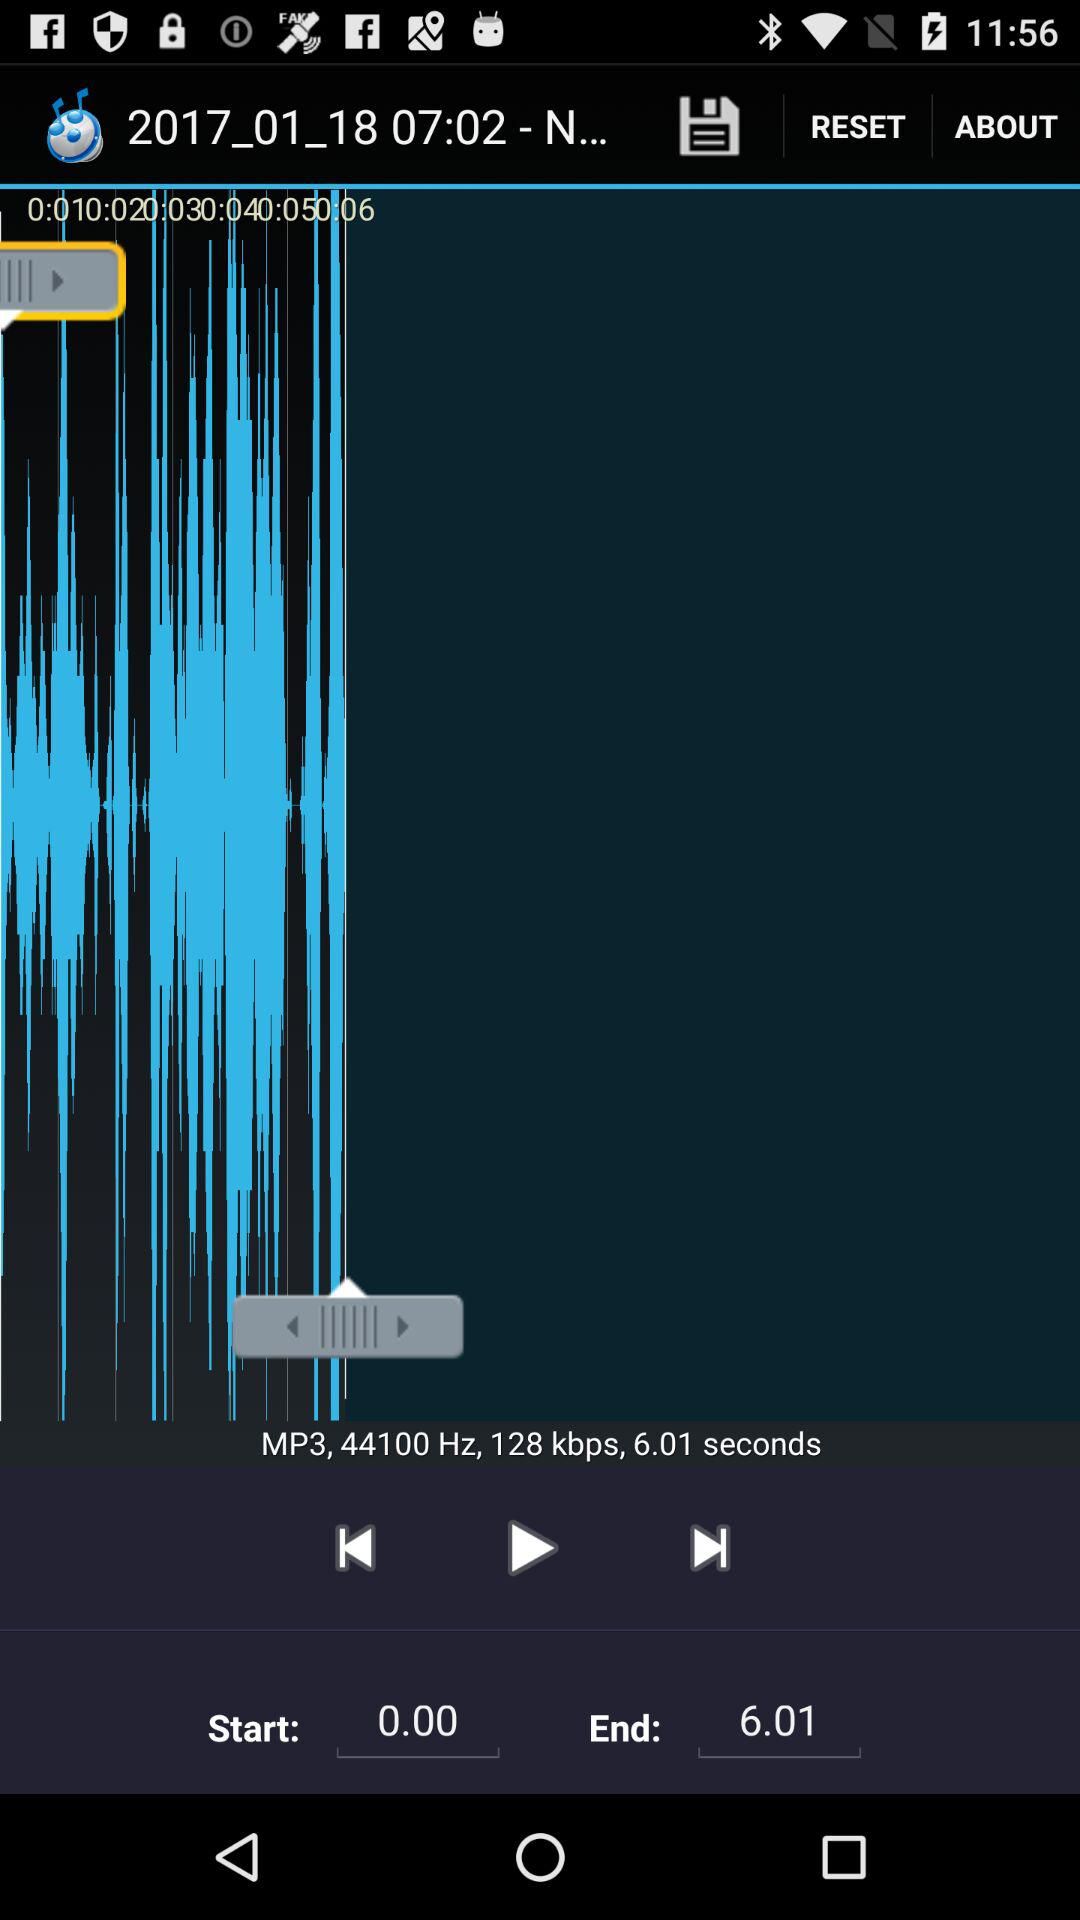How many audio files are saved?
When the provided information is insufficient, respond with <no answer>. <no answer> 